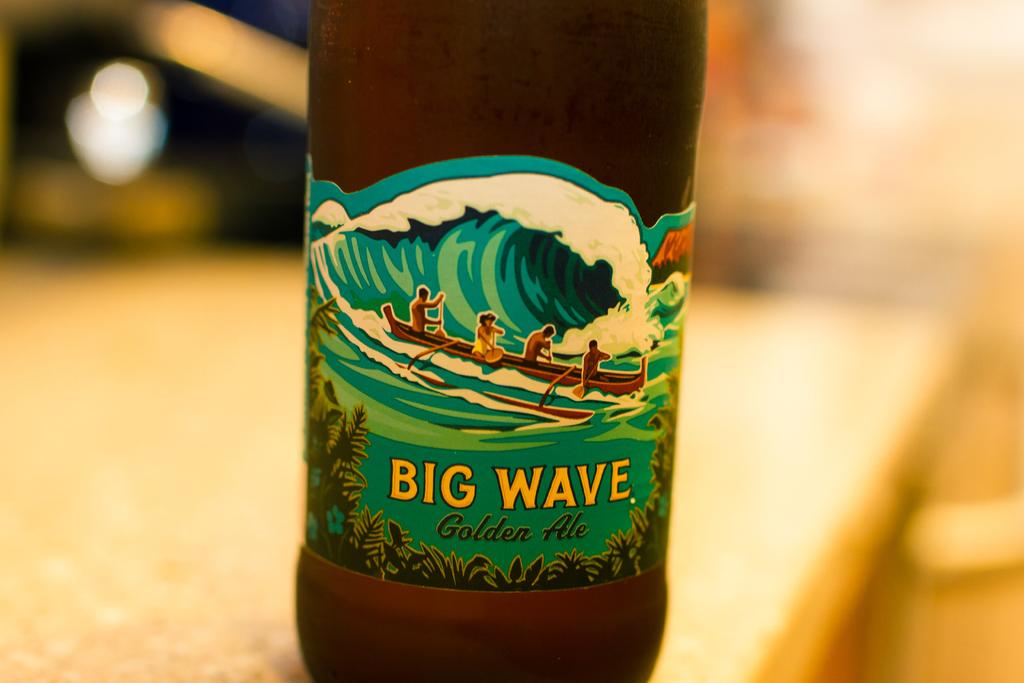What is the name of this ale?
Ensure brevity in your answer.  Big wave. What type of drink is big wave?
Provide a short and direct response. Golden ale. 